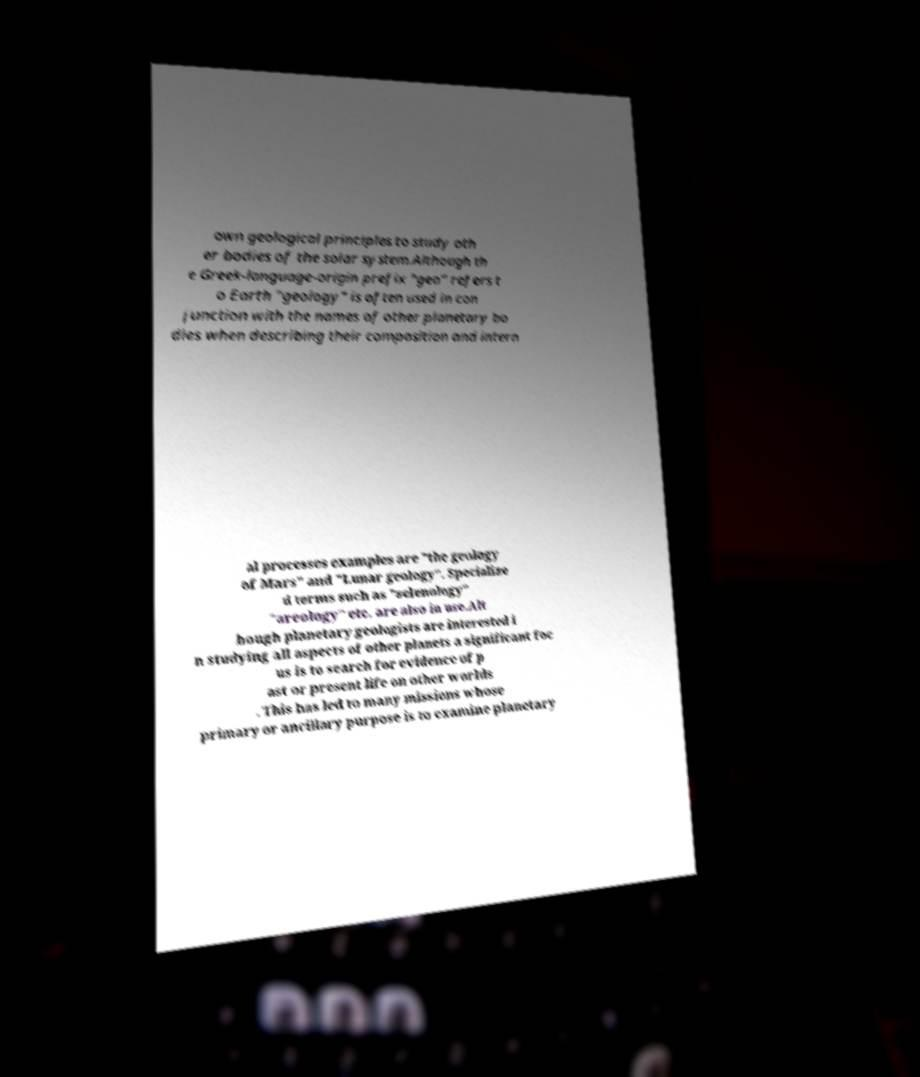Could you extract and type out the text from this image? own geological principles to study oth er bodies of the solar system.Although th e Greek-language-origin prefix "geo" refers t o Earth "geology" is often used in con junction with the names of other planetary bo dies when describing their composition and intern al processes examples are "the geology of Mars" and "Lunar geology". Specialize d terms such as "selenology" "areology" etc. are also in use.Alt hough planetary geologists are interested i n studying all aspects of other planets a significant foc us is to search for evidence of p ast or present life on other worlds . This has led to many missions whose primary or ancillary purpose is to examine planetary 